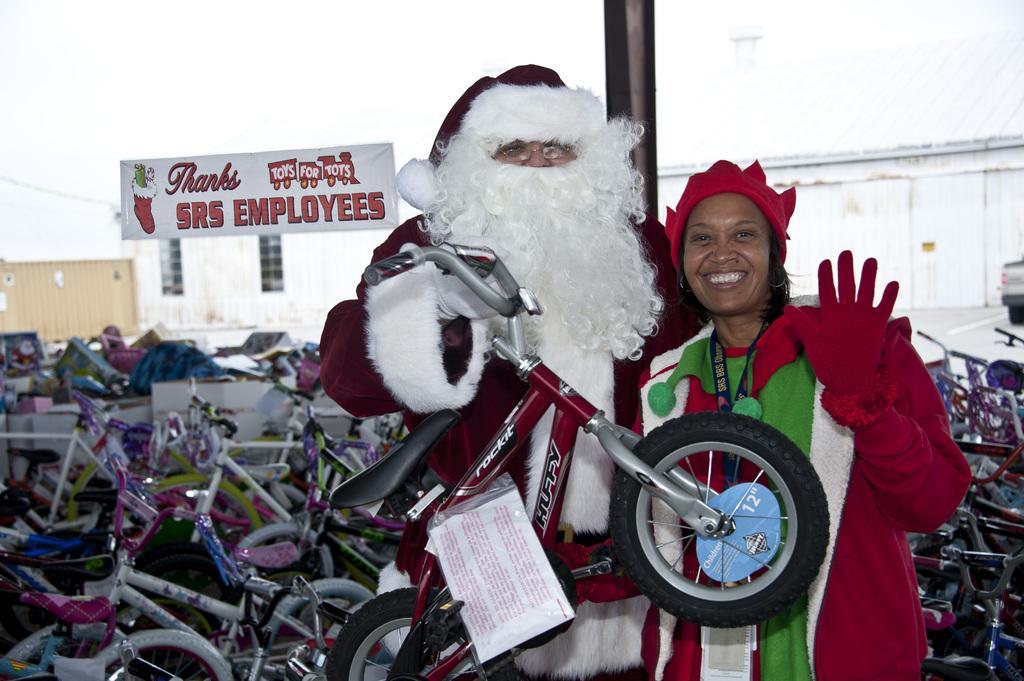In one or two sentences, can you explain what this image depicts? In this image I can see two persons are standing and holding a bicycle in hand. In the background I can see group of bicycles on the floor, house, board and a wall. This image is taken in a shop. 